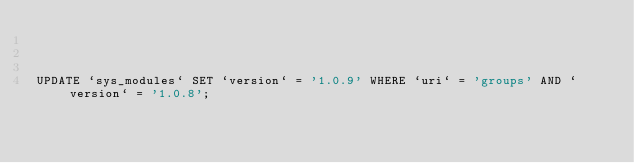Convert code to text. <code><loc_0><loc_0><loc_500><loc_500><_SQL_>


UPDATE `sys_modules` SET `version` = '1.0.9' WHERE `uri` = 'groups' AND `version` = '1.0.8';

</code> 